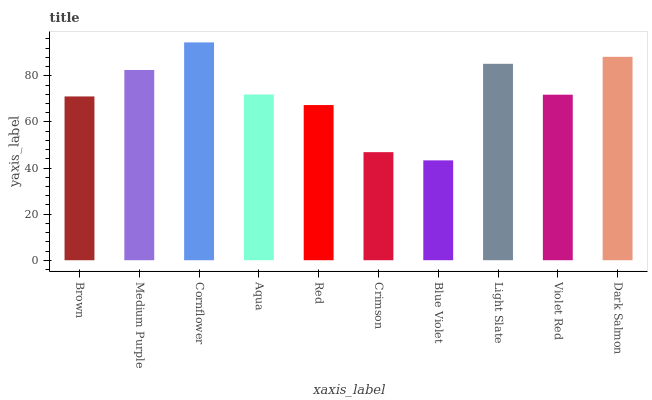Is Blue Violet the minimum?
Answer yes or no. Yes. Is Cornflower the maximum?
Answer yes or no. Yes. Is Medium Purple the minimum?
Answer yes or no. No. Is Medium Purple the maximum?
Answer yes or no. No. Is Medium Purple greater than Brown?
Answer yes or no. Yes. Is Brown less than Medium Purple?
Answer yes or no. Yes. Is Brown greater than Medium Purple?
Answer yes or no. No. Is Medium Purple less than Brown?
Answer yes or no. No. Is Aqua the high median?
Answer yes or no. Yes. Is Violet Red the low median?
Answer yes or no. Yes. Is Red the high median?
Answer yes or no. No. Is Red the low median?
Answer yes or no. No. 